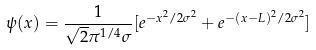Convert formula to latex. <formula><loc_0><loc_0><loc_500><loc_500>\psi ( x ) = \frac { 1 } { \sqrt { 2 } \pi ^ { 1 / 4 } \sigma } [ e ^ { - x ^ { 2 } / 2 \sigma ^ { 2 } } + e ^ { - ( x - L ) ^ { 2 } / 2 \sigma ^ { 2 } } ]</formula> 